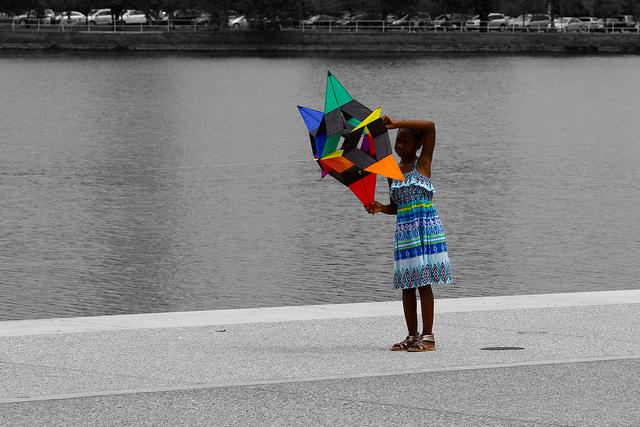Where does the girl want the toy she holds to go? air 